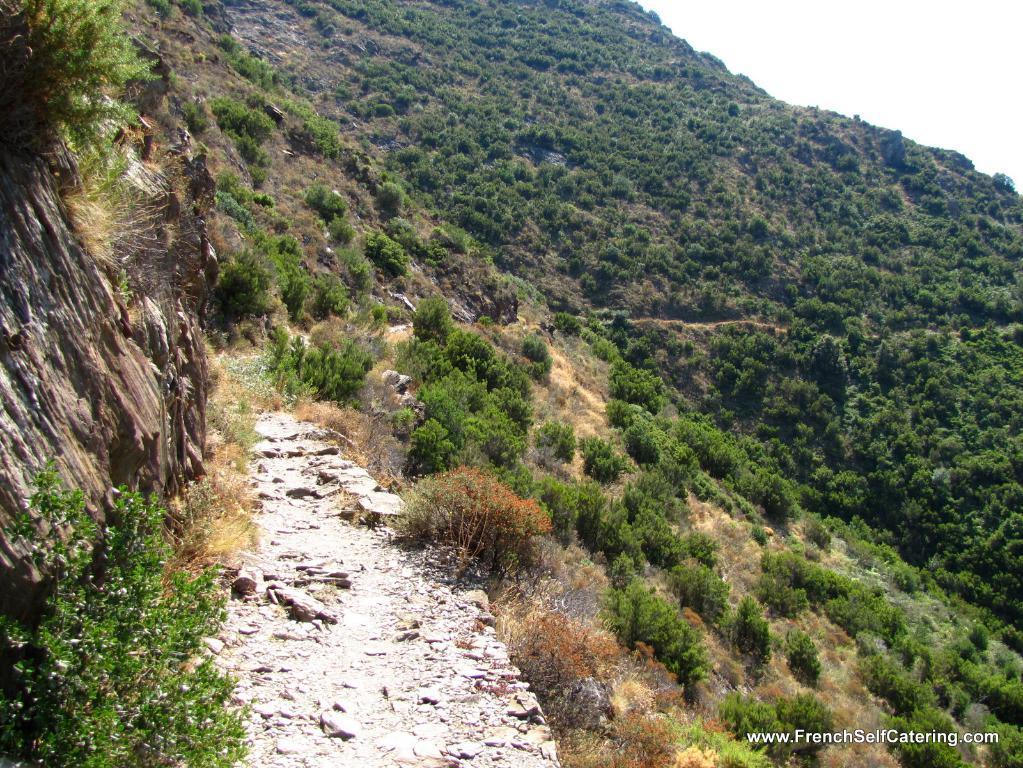How would you summarize this image in a sentence or two? This image is taken outdoors. In this image there are a few hills with grass, plants and many trees. 